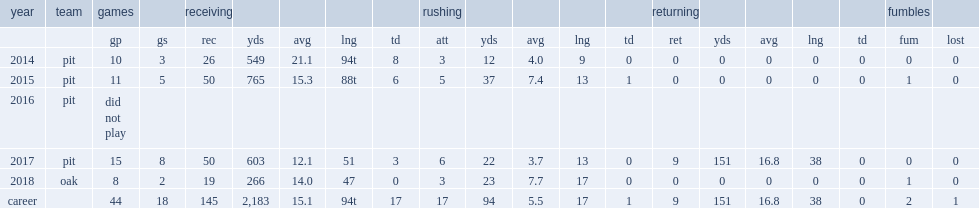How many receiving yards did martavis bryant get in 2014? 549.0. 